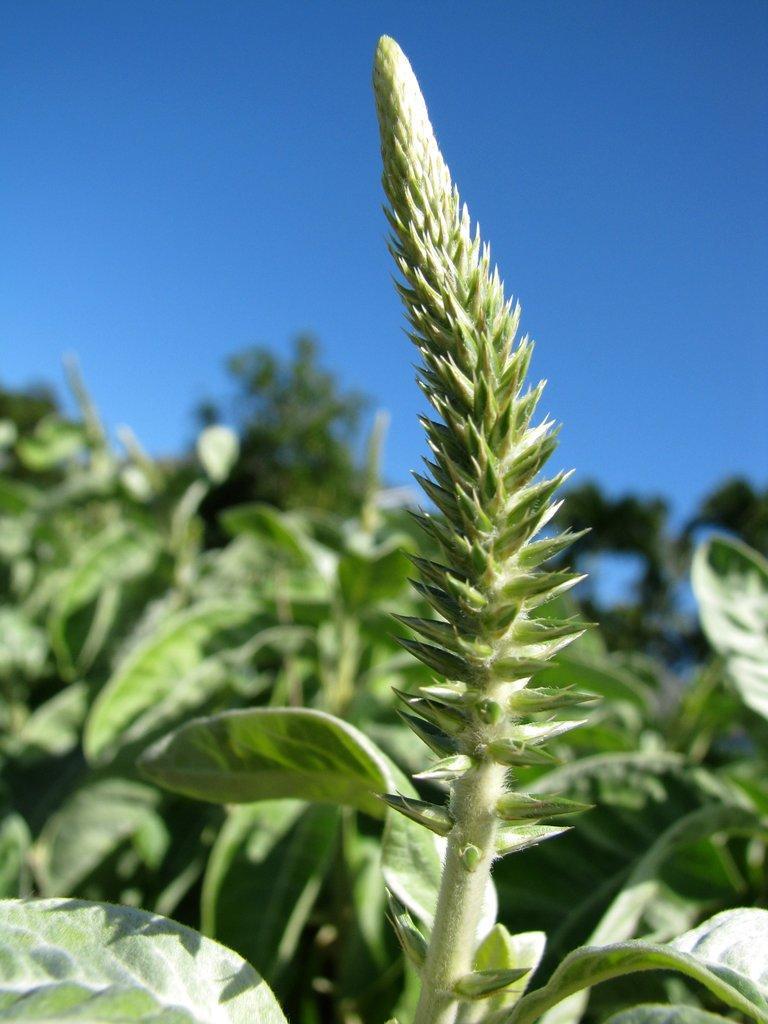Could you give a brief overview of what you see in this image? In this picture we can observe plants on the ground. They are in green color. There is a sky in the background. 